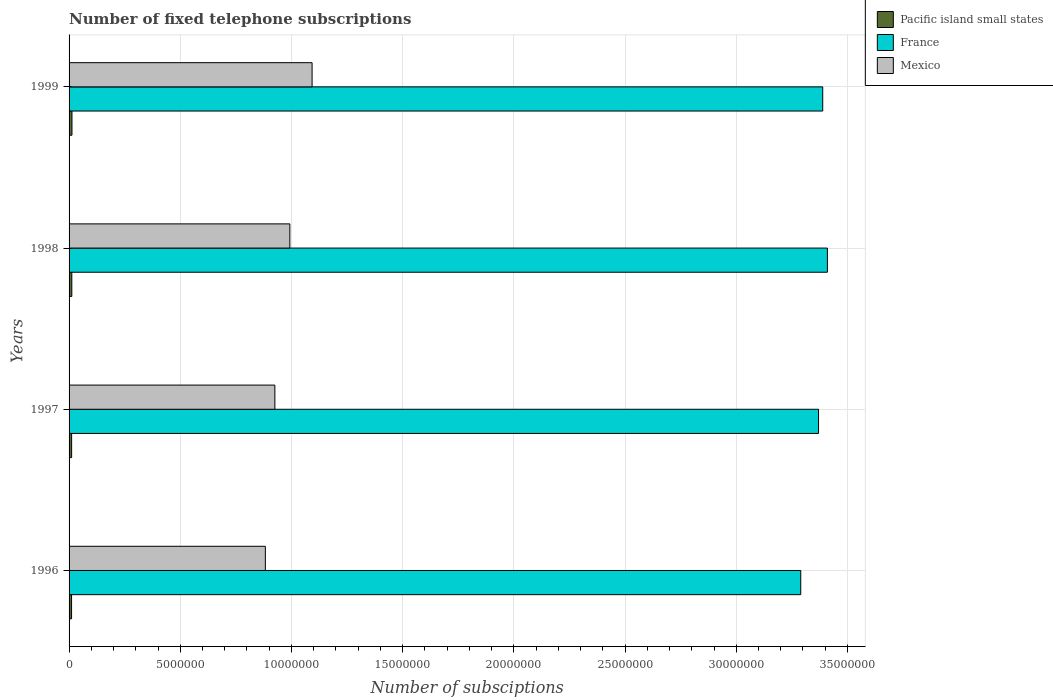How many different coloured bars are there?
Offer a terse response. 3. How many groups of bars are there?
Make the answer very short. 4. How many bars are there on the 3rd tick from the bottom?
Keep it short and to the point. 3. What is the label of the 4th group of bars from the top?
Your answer should be very brief. 1996. What is the number of fixed telephone subscriptions in France in 1999?
Your response must be concise. 3.39e+07. Across all years, what is the maximum number of fixed telephone subscriptions in Mexico?
Offer a terse response. 1.09e+07. Across all years, what is the minimum number of fixed telephone subscriptions in Pacific island small states?
Your answer should be compact. 1.12e+05. In which year was the number of fixed telephone subscriptions in France maximum?
Your answer should be compact. 1998. What is the total number of fixed telephone subscriptions in Pacific island small states in the graph?
Offer a terse response. 4.80e+05. What is the difference between the number of fixed telephone subscriptions in France in 1998 and that in 1999?
Ensure brevity in your answer.  2.11e+05. What is the difference between the number of fixed telephone subscriptions in France in 1996 and the number of fixed telephone subscriptions in Mexico in 1997?
Offer a terse response. 2.36e+07. What is the average number of fixed telephone subscriptions in Pacific island small states per year?
Provide a succinct answer. 1.20e+05. In the year 1999, what is the difference between the number of fixed telephone subscriptions in Pacific island small states and number of fixed telephone subscriptions in Mexico?
Offer a very short reply. -1.08e+07. What is the ratio of the number of fixed telephone subscriptions in France in 1996 to that in 1998?
Ensure brevity in your answer.  0.96. What is the difference between the highest and the second highest number of fixed telephone subscriptions in Mexico?
Your answer should be very brief. 1.00e+06. What is the difference between the highest and the lowest number of fixed telephone subscriptions in Mexico?
Offer a terse response. 2.10e+06. In how many years, is the number of fixed telephone subscriptions in Mexico greater than the average number of fixed telephone subscriptions in Mexico taken over all years?
Offer a very short reply. 2. Is the sum of the number of fixed telephone subscriptions in Mexico in 1996 and 1998 greater than the maximum number of fixed telephone subscriptions in France across all years?
Offer a terse response. No. What does the 2nd bar from the top in 1999 represents?
Give a very brief answer. France. Is it the case that in every year, the sum of the number of fixed telephone subscriptions in Pacific island small states and number of fixed telephone subscriptions in France is greater than the number of fixed telephone subscriptions in Mexico?
Provide a short and direct response. Yes. How many years are there in the graph?
Offer a terse response. 4. Are the values on the major ticks of X-axis written in scientific E-notation?
Your answer should be very brief. No. Where does the legend appear in the graph?
Ensure brevity in your answer.  Top right. How are the legend labels stacked?
Ensure brevity in your answer.  Vertical. What is the title of the graph?
Offer a very short reply. Number of fixed telephone subscriptions. What is the label or title of the X-axis?
Offer a very short reply. Number of subsciptions. What is the label or title of the Y-axis?
Make the answer very short. Years. What is the Number of subsciptions of Pacific island small states in 1996?
Make the answer very short. 1.12e+05. What is the Number of subsciptions in France in 1996?
Keep it short and to the point. 3.29e+07. What is the Number of subsciptions in Mexico in 1996?
Provide a succinct answer. 8.83e+06. What is the Number of subsciptions in Pacific island small states in 1997?
Offer a terse response. 1.15e+05. What is the Number of subsciptions of France in 1997?
Ensure brevity in your answer.  3.37e+07. What is the Number of subsciptions of Mexico in 1997?
Give a very brief answer. 9.25e+06. What is the Number of subsciptions of Pacific island small states in 1998?
Your answer should be compact. 1.23e+05. What is the Number of subsciptions in France in 1998?
Provide a succinct answer. 3.41e+07. What is the Number of subsciptions of Mexico in 1998?
Offer a terse response. 9.93e+06. What is the Number of subsciptions of Pacific island small states in 1999?
Offer a terse response. 1.30e+05. What is the Number of subsciptions of France in 1999?
Offer a very short reply. 3.39e+07. What is the Number of subsciptions in Mexico in 1999?
Give a very brief answer. 1.09e+07. Across all years, what is the maximum Number of subsciptions in Pacific island small states?
Offer a very short reply. 1.30e+05. Across all years, what is the maximum Number of subsciptions in France?
Your answer should be very brief. 3.41e+07. Across all years, what is the maximum Number of subsciptions of Mexico?
Offer a very short reply. 1.09e+07. Across all years, what is the minimum Number of subsciptions in Pacific island small states?
Provide a short and direct response. 1.12e+05. Across all years, what is the minimum Number of subsciptions in France?
Ensure brevity in your answer.  3.29e+07. Across all years, what is the minimum Number of subsciptions of Mexico?
Keep it short and to the point. 8.83e+06. What is the total Number of subsciptions in Pacific island small states in the graph?
Your answer should be very brief. 4.80e+05. What is the total Number of subsciptions in France in the graph?
Provide a short and direct response. 1.35e+08. What is the total Number of subsciptions in Mexico in the graph?
Offer a very short reply. 3.89e+07. What is the difference between the Number of subsciptions in Pacific island small states in 1996 and that in 1997?
Offer a terse response. -2898. What is the difference between the Number of subsciptions of France in 1996 and that in 1997?
Your response must be concise. -8.00e+05. What is the difference between the Number of subsciptions in Mexico in 1996 and that in 1997?
Offer a terse response. -4.28e+05. What is the difference between the Number of subsciptions in Pacific island small states in 1996 and that in 1998?
Keep it short and to the point. -1.13e+04. What is the difference between the Number of subsciptions of France in 1996 and that in 1998?
Make the answer very short. -1.20e+06. What is the difference between the Number of subsciptions of Mexico in 1996 and that in 1998?
Ensure brevity in your answer.  -1.10e+06. What is the difference between the Number of subsciptions of Pacific island small states in 1996 and that in 1999?
Give a very brief answer. -1.82e+04. What is the difference between the Number of subsciptions of France in 1996 and that in 1999?
Your answer should be compact. -9.88e+05. What is the difference between the Number of subsciptions of Mexico in 1996 and that in 1999?
Offer a terse response. -2.10e+06. What is the difference between the Number of subsciptions of Pacific island small states in 1997 and that in 1998?
Ensure brevity in your answer.  -8387. What is the difference between the Number of subsciptions of France in 1997 and that in 1998?
Make the answer very short. -3.99e+05. What is the difference between the Number of subsciptions of Mexico in 1997 and that in 1998?
Keep it short and to the point. -6.73e+05. What is the difference between the Number of subsciptions of Pacific island small states in 1997 and that in 1999?
Ensure brevity in your answer.  -1.53e+04. What is the difference between the Number of subsciptions in France in 1997 and that in 1999?
Your answer should be very brief. -1.88e+05. What is the difference between the Number of subsciptions in Mexico in 1997 and that in 1999?
Offer a very short reply. -1.67e+06. What is the difference between the Number of subsciptions in Pacific island small states in 1998 and that in 1999?
Provide a short and direct response. -6962. What is the difference between the Number of subsciptions of France in 1998 and that in 1999?
Provide a short and direct response. 2.11e+05. What is the difference between the Number of subsciptions of Mexico in 1998 and that in 1999?
Provide a succinct answer. -1.00e+06. What is the difference between the Number of subsciptions of Pacific island small states in 1996 and the Number of subsciptions of France in 1997?
Give a very brief answer. -3.36e+07. What is the difference between the Number of subsciptions in Pacific island small states in 1996 and the Number of subsciptions in Mexico in 1997?
Offer a very short reply. -9.14e+06. What is the difference between the Number of subsciptions in France in 1996 and the Number of subsciptions in Mexico in 1997?
Your answer should be compact. 2.36e+07. What is the difference between the Number of subsciptions in Pacific island small states in 1996 and the Number of subsciptions in France in 1998?
Provide a succinct answer. -3.40e+07. What is the difference between the Number of subsciptions in Pacific island small states in 1996 and the Number of subsciptions in Mexico in 1998?
Your response must be concise. -9.81e+06. What is the difference between the Number of subsciptions in France in 1996 and the Number of subsciptions in Mexico in 1998?
Offer a very short reply. 2.30e+07. What is the difference between the Number of subsciptions in Pacific island small states in 1996 and the Number of subsciptions in France in 1999?
Provide a short and direct response. -3.38e+07. What is the difference between the Number of subsciptions of Pacific island small states in 1996 and the Number of subsciptions of Mexico in 1999?
Keep it short and to the point. -1.08e+07. What is the difference between the Number of subsciptions in France in 1996 and the Number of subsciptions in Mexico in 1999?
Offer a terse response. 2.20e+07. What is the difference between the Number of subsciptions of Pacific island small states in 1997 and the Number of subsciptions of France in 1998?
Offer a very short reply. -3.40e+07. What is the difference between the Number of subsciptions of Pacific island small states in 1997 and the Number of subsciptions of Mexico in 1998?
Keep it short and to the point. -9.81e+06. What is the difference between the Number of subsciptions in France in 1997 and the Number of subsciptions in Mexico in 1998?
Offer a terse response. 2.38e+07. What is the difference between the Number of subsciptions of Pacific island small states in 1997 and the Number of subsciptions of France in 1999?
Your response must be concise. -3.38e+07. What is the difference between the Number of subsciptions of Pacific island small states in 1997 and the Number of subsciptions of Mexico in 1999?
Keep it short and to the point. -1.08e+07. What is the difference between the Number of subsciptions of France in 1997 and the Number of subsciptions of Mexico in 1999?
Ensure brevity in your answer.  2.28e+07. What is the difference between the Number of subsciptions in Pacific island small states in 1998 and the Number of subsciptions in France in 1999?
Provide a succinct answer. -3.38e+07. What is the difference between the Number of subsciptions of Pacific island small states in 1998 and the Number of subsciptions of Mexico in 1999?
Keep it short and to the point. -1.08e+07. What is the difference between the Number of subsciptions in France in 1998 and the Number of subsciptions in Mexico in 1999?
Offer a very short reply. 2.32e+07. What is the average Number of subsciptions of Pacific island small states per year?
Your answer should be compact. 1.20e+05. What is the average Number of subsciptions of France per year?
Offer a very short reply. 3.36e+07. What is the average Number of subsciptions in Mexico per year?
Offer a terse response. 9.73e+06. In the year 1996, what is the difference between the Number of subsciptions of Pacific island small states and Number of subsciptions of France?
Your answer should be compact. -3.28e+07. In the year 1996, what is the difference between the Number of subsciptions in Pacific island small states and Number of subsciptions in Mexico?
Your answer should be very brief. -8.71e+06. In the year 1996, what is the difference between the Number of subsciptions of France and Number of subsciptions of Mexico?
Make the answer very short. 2.41e+07. In the year 1997, what is the difference between the Number of subsciptions of Pacific island small states and Number of subsciptions of France?
Provide a succinct answer. -3.36e+07. In the year 1997, what is the difference between the Number of subsciptions of Pacific island small states and Number of subsciptions of Mexico?
Give a very brief answer. -9.14e+06. In the year 1997, what is the difference between the Number of subsciptions in France and Number of subsciptions in Mexico?
Keep it short and to the point. 2.44e+07. In the year 1998, what is the difference between the Number of subsciptions of Pacific island small states and Number of subsciptions of France?
Provide a short and direct response. -3.40e+07. In the year 1998, what is the difference between the Number of subsciptions of Pacific island small states and Number of subsciptions of Mexico?
Offer a very short reply. -9.80e+06. In the year 1998, what is the difference between the Number of subsciptions of France and Number of subsciptions of Mexico?
Keep it short and to the point. 2.42e+07. In the year 1999, what is the difference between the Number of subsciptions of Pacific island small states and Number of subsciptions of France?
Your response must be concise. -3.38e+07. In the year 1999, what is the difference between the Number of subsciptions of Pacific island small states and Number of subsciptions of Mexico?
Ensure brevity in your answer.  -1.08e+07. In the year 1999, what is the difference between the Number of subsciptions of France and Number of subsciptions of Mexico?
Give a very brief answer. 2.30e+07. What is the ratio of the Number of subsciptions of Pacific island small states in 1996 to that in 1997?
Your answer should be compact. 0.97. What is the ratio of the Number of subsciptions of France in 1996 to that in 1997?
Make the answer very short. 0.98. What is the ratio of the Number of subsciptions in Mexico in 1996 to that in 1997?
Your response must be concise. 0.95. What is the ratio of the Number of subsciptions of Pacific island small states in 1996 to that in 1998?
Ensure brevity in your answer.  0.91. What is the ratio of the Number of subsciptions in France in 1996 to that in 1998?
Your response must be concise. 0.96. What is the ratio of the Number of subsciptions in Mexico in 1996 to that in 1998?
Your answer should be compact. 0.89. What is the ratio of the Number of subsciptions in Pacific island small states in 1996 to that in 1999?
Make the answer very short. 0.86. What is the ratio of the Number of subsciptions of France in 1996 to that in 1999?
Your answer should be compact. 0.97. What is the ratio of the Number of subsciptions of Mexico in 1996 to that in 1999?
Offer a terse response. 0.81. What is the ratio of the Number of subsciptions of Pacific island small states in 1997 to that in 1998?
Give a very brief answer. 0.93. What is the ratio of the Number of subsciptions of France in 1997 to that in 1998?
Your response must be concise. 0.99. What is the ratio of the Number of subsciptions of Mexico in 1997 to that in 1998?
Your answer should be compact. 0.93. What is the ratio of the Number of subsciptions of Pacific island small states in 1997 to that in 1999?
Your response must be concise. 0.88. What is the ratio of the Number of subsciptions of France in 1997 to that in 1999?
Your response must be concise. 0.99. What is the ratio of the Number of subsciptions of Mexico in 1997 to that in 1999?
Your answer should be very brief. 0.85. What is the ratio of the Number of subsciptions of Pacific island small states in 1998 to that in 1999?
Ensure brevity in your answer.  0.95. What is the ratio of the Number of subsciptions of Mexico in 1998 to that in 1999?
Make the answer very short. 0.91. What is the difference between the highest and the second highest Number of subsciptions in Pacific island small states?
Your response must be concise. 6962. What is the difference between the highest and the second highest Number of subsciptions in France?
Your answer should be compact. 2.11e+05. What is the difference between the highest and the second highest Number of subsciptions in Mexico?
Your answer should be very brief. 1.00e+06. What is the difference between the highest and the lowest Number of subsciptions in Pacific island small states?
Your answer should be very brief. 1.82e+04. What is the difference between the highest and the lowest Number of subsciptions of France?
Provide a short and direct response. 1.20e+06. What is the difference between the highest and the lowest Number of subsciptions in Mexico?
Your answer should be very brief. 2.10e+06. 